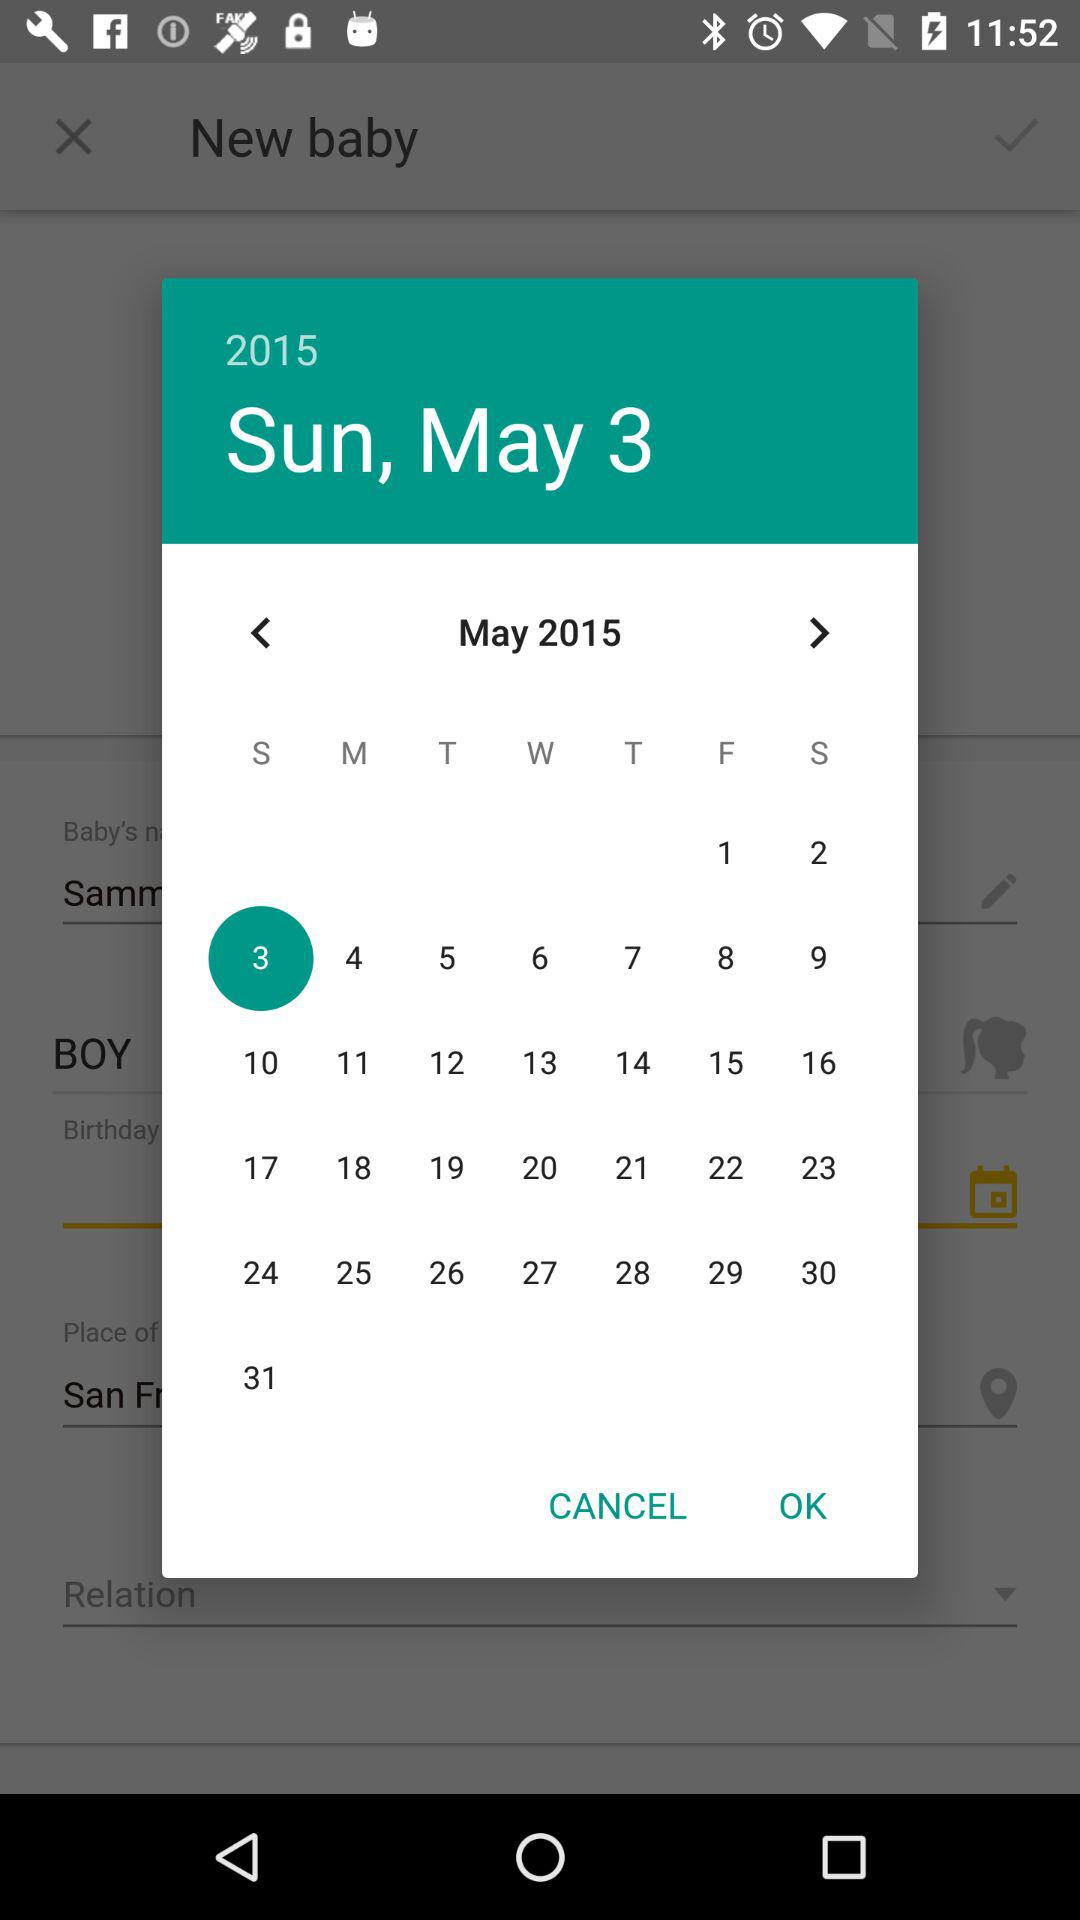What is the day on May 3? The day is Sunday. 